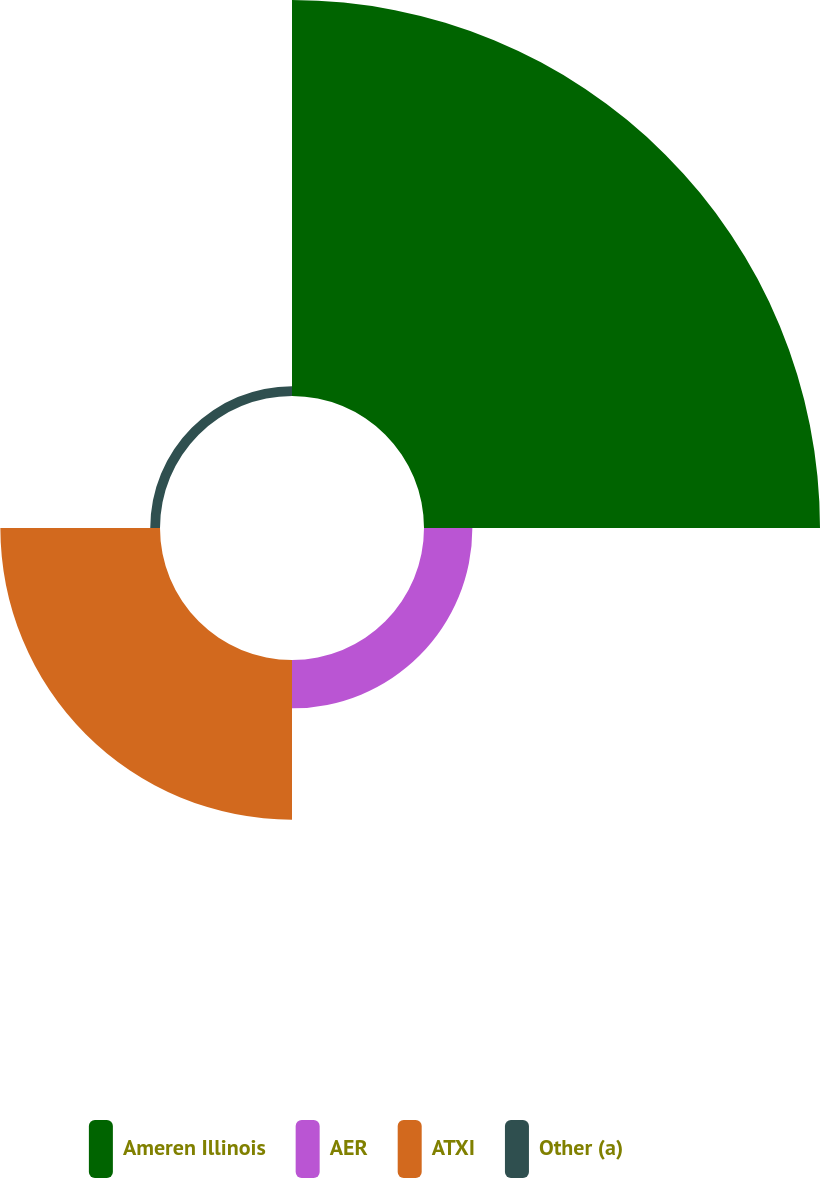Convert chart. <chart><loc_0><loc_0><loc_500><loc_500><pie_chart><fcel>Ameren Illinois<fcel>AER<fcel>ATXI<fcel>Other (a)<nl><fcel>64.52%<fcel>7.88%<fcel>26.01%<fcel>1.59%<nl></chart> 